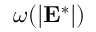<formula> <loc_0><loc_0><loc_500><loc_500>\omega ( | E ^ { * } | )</formula> 